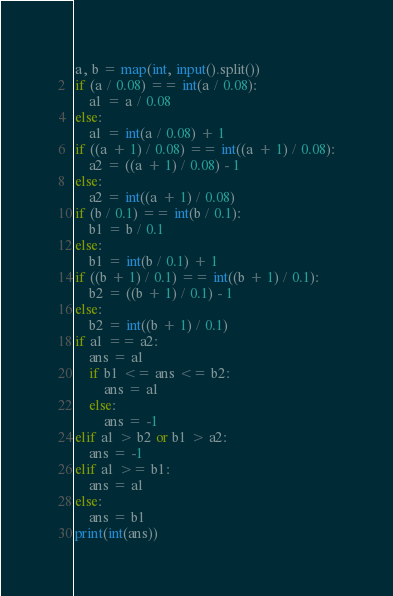Convert code to text. <code><loc_0><loc_0><loc_500><loc_500><_Python_>a, b = map(int, input().split())
if (a / 0.08) == int(a / 0.08):
    a1 = a / 0.08
else:
    a1 = int(a / 0.08) + 1
if ((a + 1) / 0.08) == int((a + 1) / 0.08):
    a2 = ((a + 1) / 0.08) - 1
else:
    a2 = int((a + 1) / 0.08)
if (b / 0.1) == int(b / 0.1):
    b1 = b / 0.1
else:
    b1 = int(b / 0.1) + 1
if ((b + 1) / 0.1) == int((b + 1) / 0.1):
    b2 = ((b + 1) / 0.1) - 1
else:
    b2 = int((b + 1) / 0.1)
if a1 == a2:
    ans = a1
    if b1 <= ans <= b2:
        ans = a1
    else:
        ans = -1
elif a1 > b2 or b1 > a2:
    ans = -1
elif a1 >= b1:
    ans = a1
else:
    ans = b1
print(int(ans))
</code> 